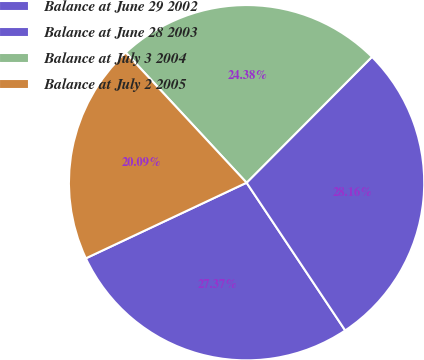<chart> <loc_0><loc_0><loc_500><loc_500><pie_chart><fcel>Balance at June 29 2002<fcel>Balance at June 28 2003<fcel>Balance at July 3 2004<fcel>Balance at July 2 2005<nl><fcel>27.37%<fcel>28.16%<fcel>24.38%<fcel>20.09%<nl></chart> 